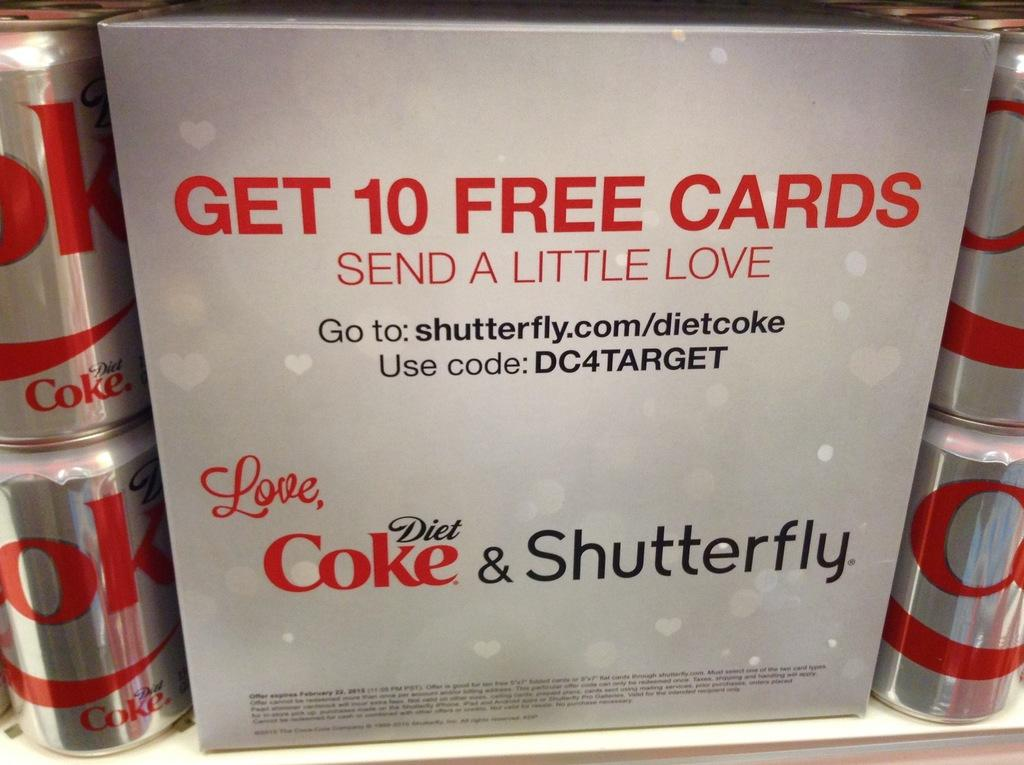<image>
Offer a succinct explanation of the picture presented. A coke promotion wity shutterfly surrounded by diet coke cans. 